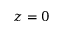<formula> <loc_0><loc_0><loc_500><loc_500>z = 0</formula> 